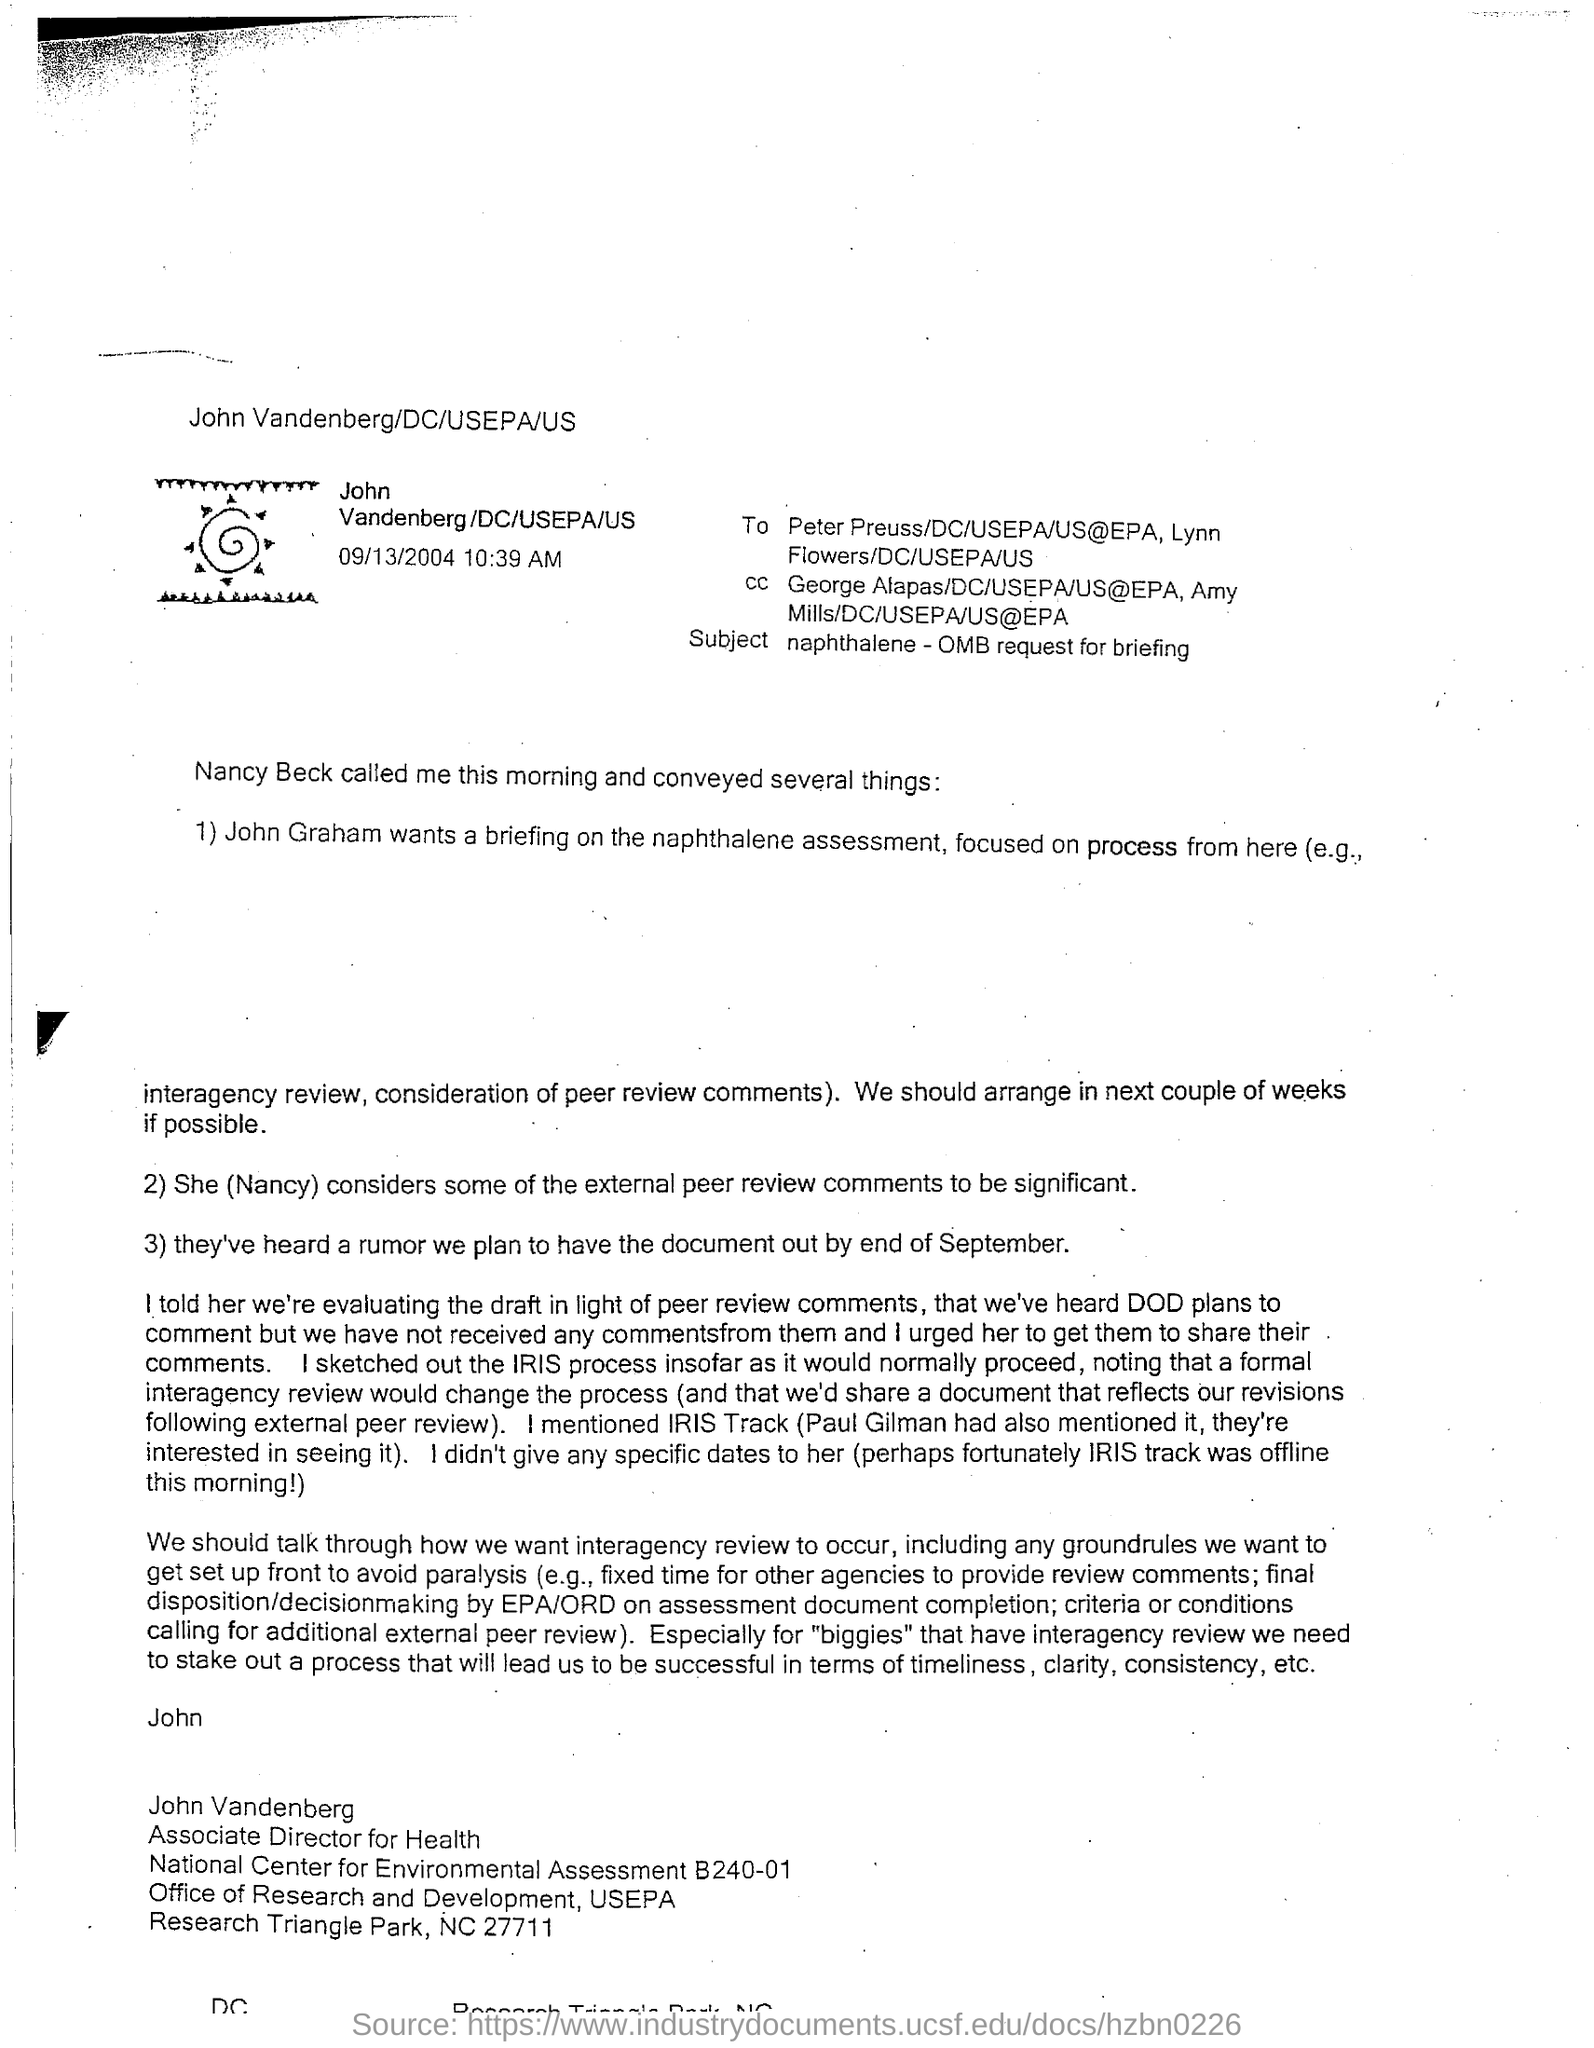Give some essential details in this illustration. The email was sent by John. The subject of the email is "Naphthalene - OMB request for briefing. John Vandenberg has been designated as the Associate Director for Health at [insert organization name]. The sent date and time of the email is September 13, 2004 at 10:39 AM. 